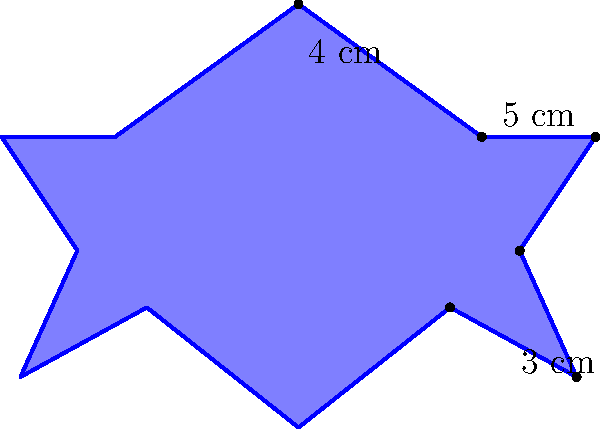As a seasoned diplomat, you're tasked with verifying the specifications of a new star-shaped diplomatic seal. The seal has 12 identical points, and you're given the following measurements for three of its sides: 4 cm, 5 cm, and 3 cm, as shown in the diagram. Calculate the perimeter of the entire seal. To calculate the perimeter of the star-shaped diplomatic seal, we'll follow these steps:

1) First, observe that the star has 12 identical points, which means it has 12 identical sections.

2) Each section consists of two sides: one longer (outer) and one shorter (inner).

3) From the given information, we can deduce:
   - The longer outer side is 4 cm
   - The shorter inner side is 5 cm
   - The third measurement (3 cm) is not part of the perimeter, so we don't need it for this calculation

4) Since there are 12 identical sections, and each section has two sides, the perimeter will be:

   $Perimeter = 12 \times (4 \text{ cm} + 5 \text{ cm})$

5) Let's calculate:
   $Perimeter = 12 \times 9 \text{ cm} = 108 \text{ cm}$

Therefore, the perimeter of the entire star-shaped diplomatic seal is 108 cm.
Answer: 108 cm 